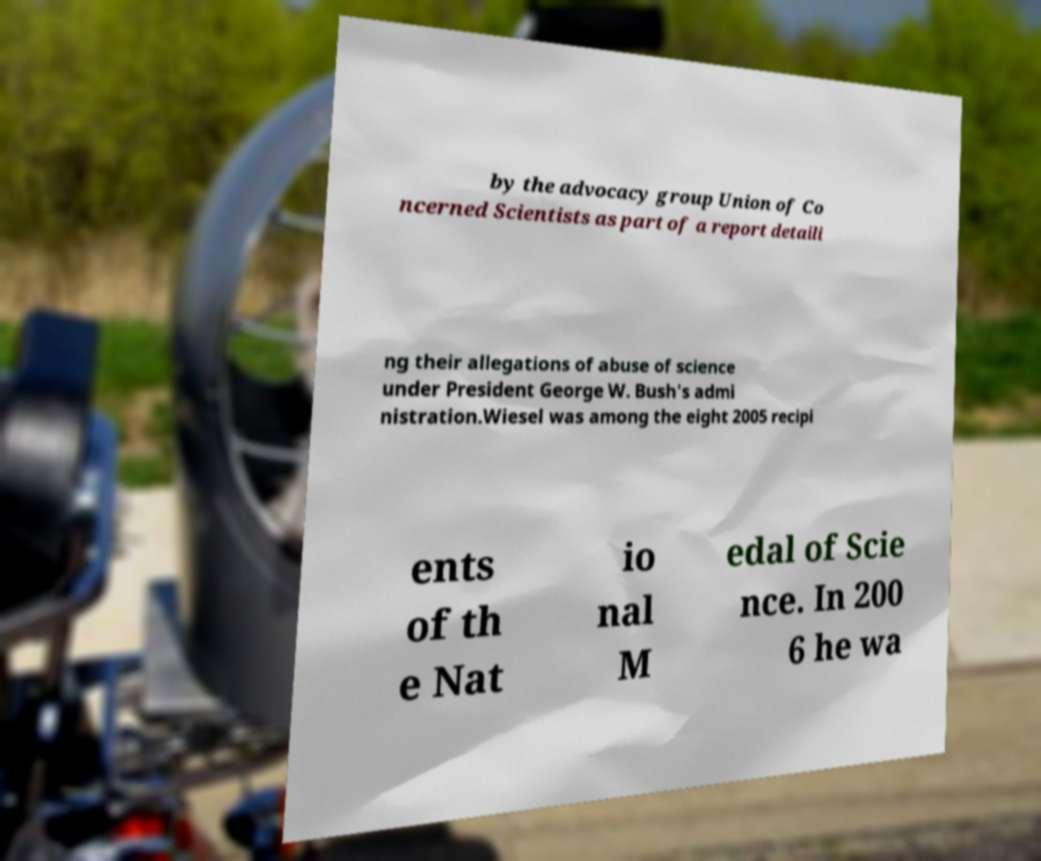Can you read and provide the text displayed in the image?This photo seems to have some interesting text. Can you extract and type it out for me? by the advocacy group Union of Co ncerned Scientists as part of a report detaili ng their allegations of abuse of science under President George W. Bush's admi nistration.Wiesel was among the eight 2005 recipi ents of th e Nat io nal M edal of Scie nce. In 200 6 he wa 